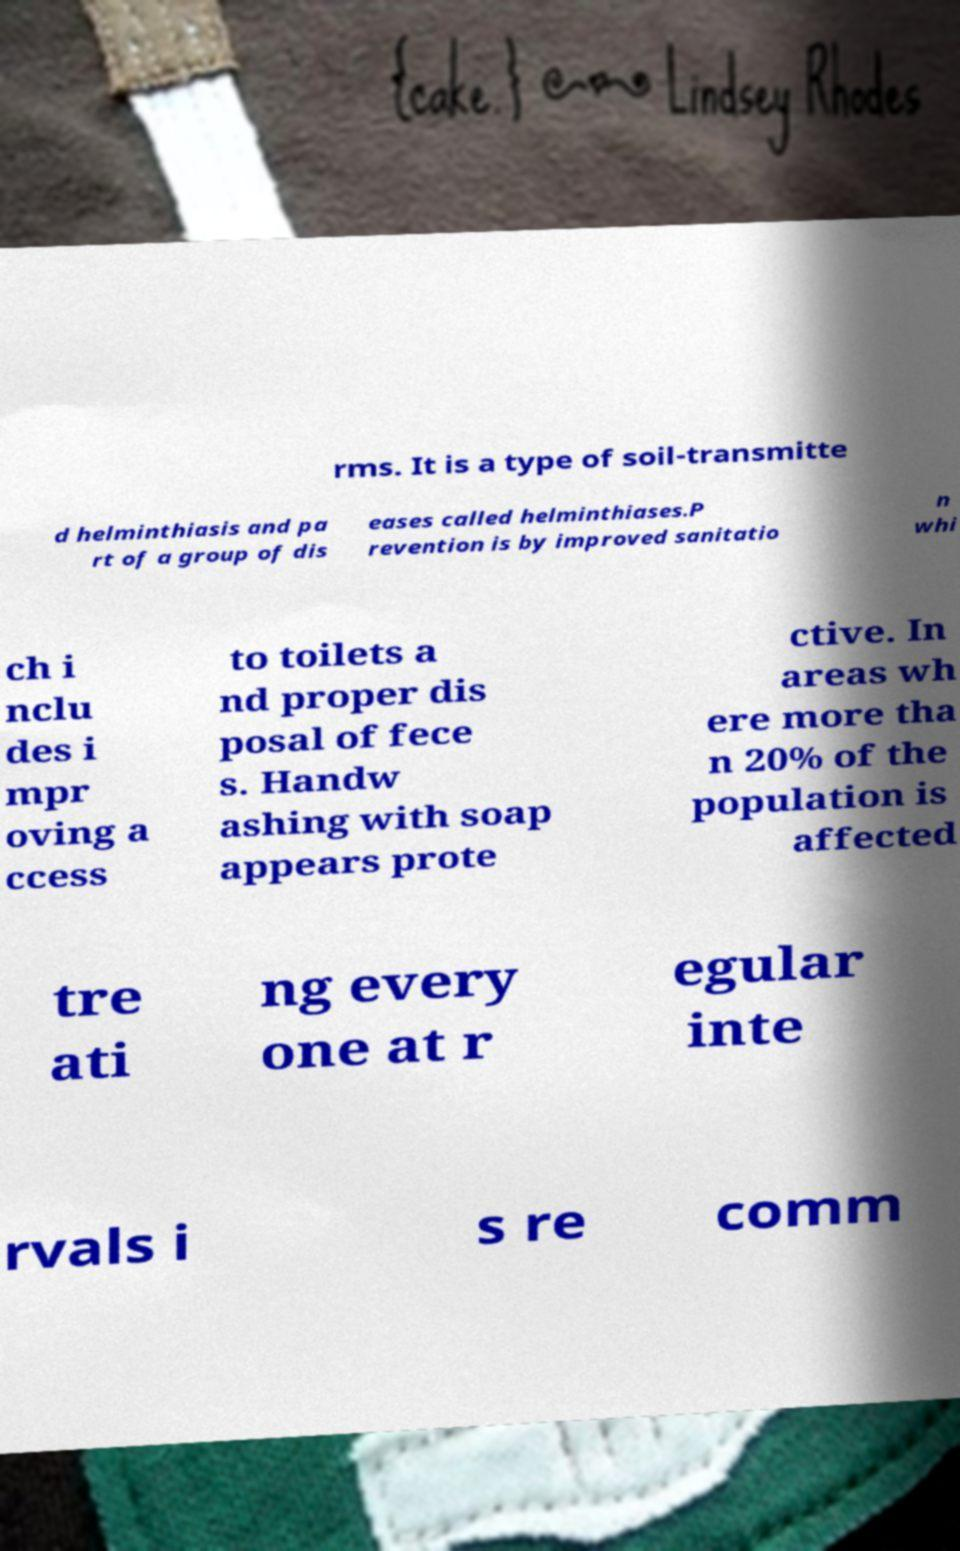Can you read and provide the text displayed in the image?This photo seems to have some interesting text. Can you extract and type it out for me? rms. It is a type of soil-transmitte d helminthiasis and pa rt of a group of dis eases called helminthiases.P revention is by improved sanitatio n whi ch i nclu des i mpr oving a ccess to toilets a nd proper dis posal of fece s. Handw ashing with soap appears prote ctive. In areas wh ere more tha n 20% of the population is affected tre ati ng every one at r egular inte rvals i s re comm 